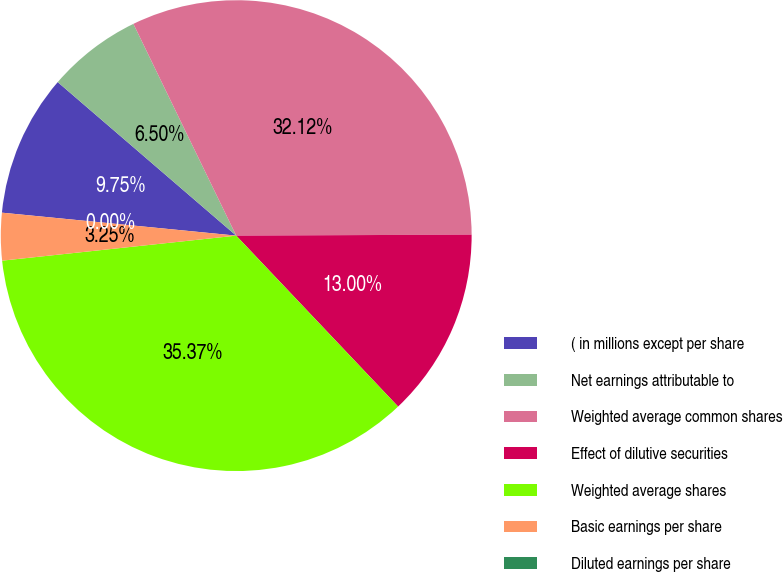Convert chart to OTSL. <chart><loc_0><loc_0><loc_500><loc_500><pie_chart><fcel>( in millions except per share<fcel>Net earnings attributable to<fcel>Weighted average common shares<fcel>Effect of dilutive securities<fcel>Weighted average shares<fcel>Basic earnings per share<fcel>Diluted earnings per share<nl><fcel>9.75%<fcel>6.5%<fcel>32.12%<fcel>13.0%<fcel>35.37%<fcel>3.25%<fcel>0.0%<nl></chart> 